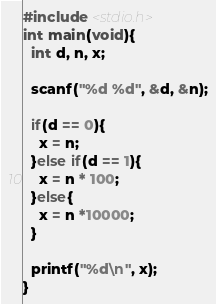Convert code to text. <code><loc_0><loc_0><loc_500><loc_500><_C_>#include <stdio.h>
int main(void){
  int d, n, x;
  
  scanf("%d %d", &d, &n);
  
  if(d == 0){
    x = n;
  }else if(d == 1){
    x = n * 100;
  }else{
    x = n *10000;
  }
  
  printf("%d\n", x);
}
</code> 